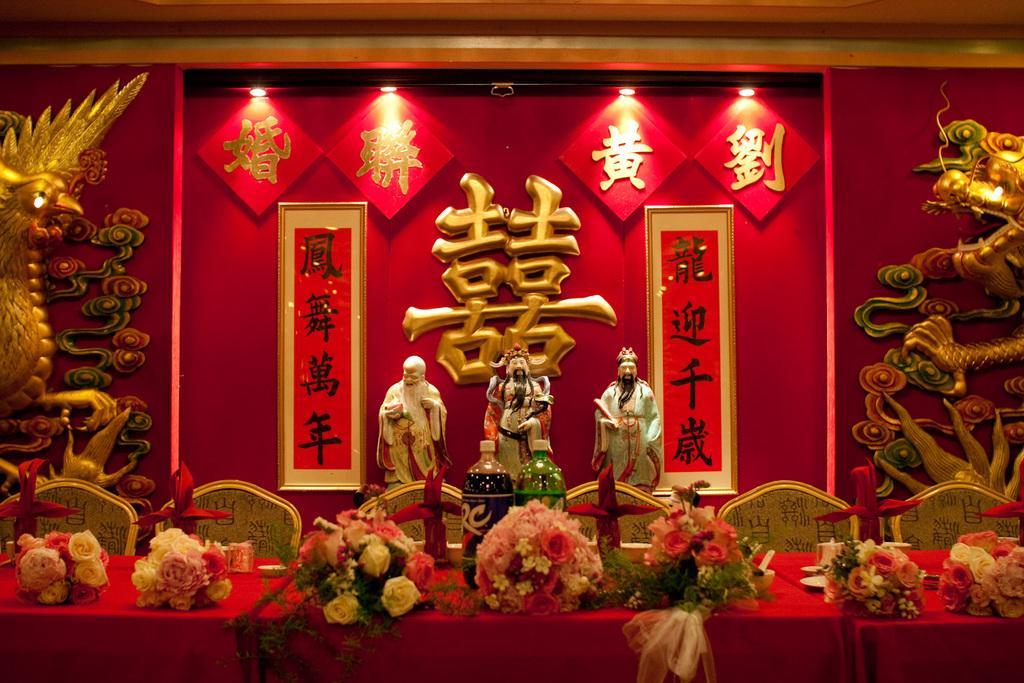Please provide a concise description of this image. In the foreground of the picture there are chairs, bouquets, bottles, tables and cloth. In the center of the picture there are statues. In the background there are lights, boards, sculptures and text. 